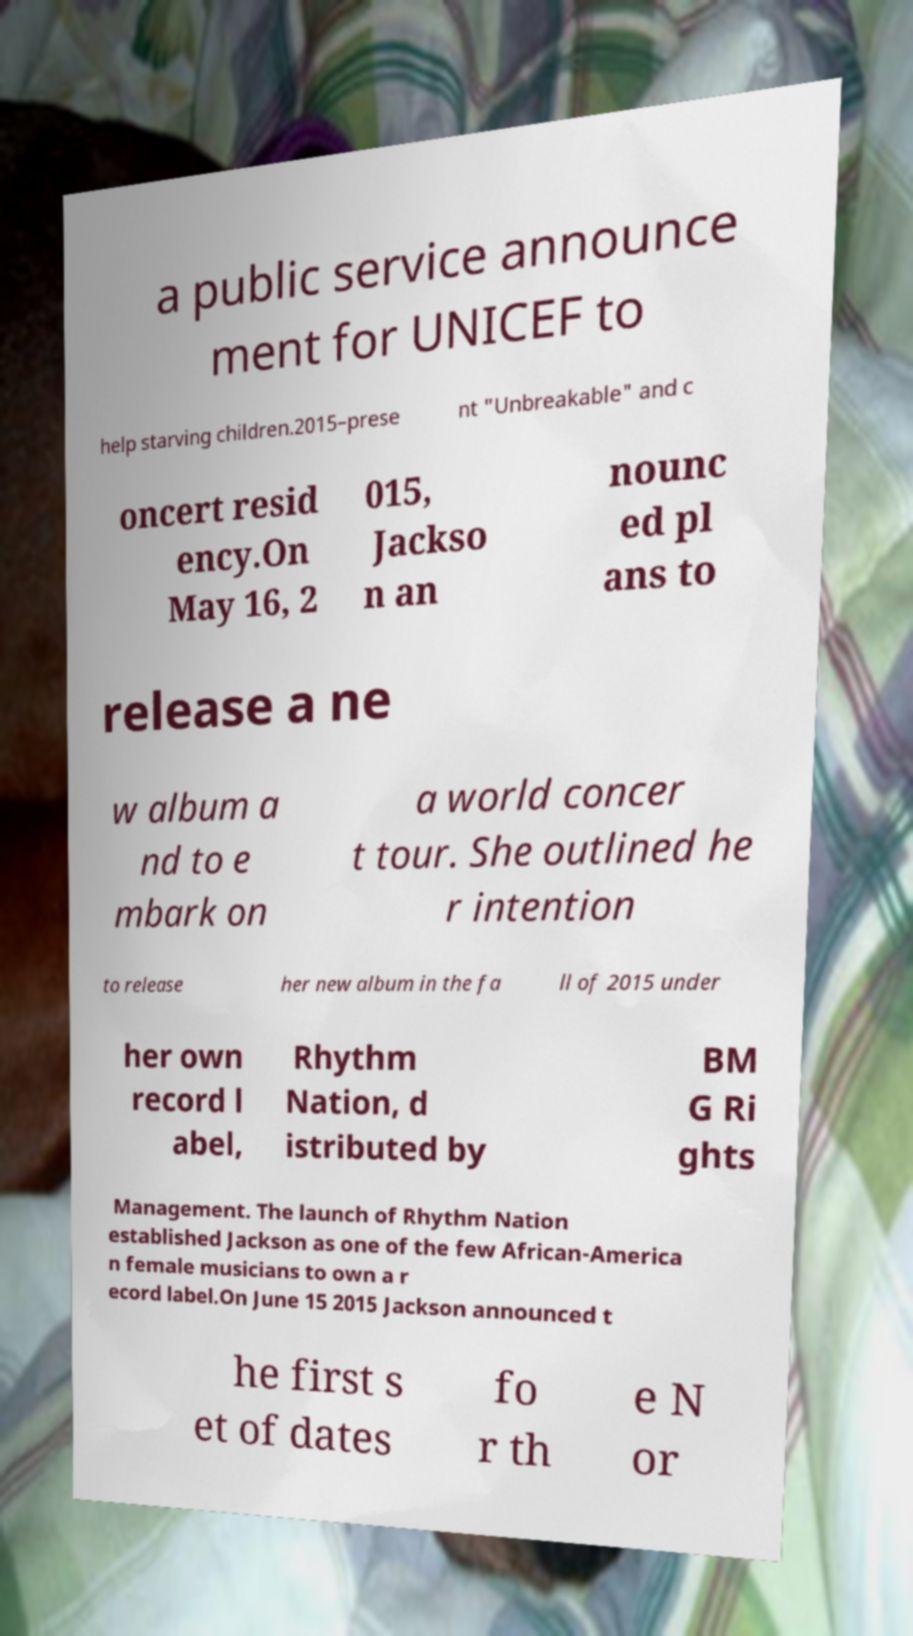There's text embedded in this image that I need extracted. Can you transcribe it verbatim? a public service announce ment for UNICEF to help starving children.2015–prese nt "Unbreakable" and c oncert resid ency.On May 16, 2 015, Jackso n an nounc ed pl ans to release a ne w album a nd to e mbark on a world concer t tour. She outlined he r intention to release her new album in the fa ll of 2015 under her own record l abel, Rhythm Nation, d istributed by BM G Ri ghts Management. The launch of Rhythm Nation established Jackson as one of the few African-America n female musicians to own a r ecord label.On June 15 2015 Jackson announced t he first s et of dates fo r th e N or 